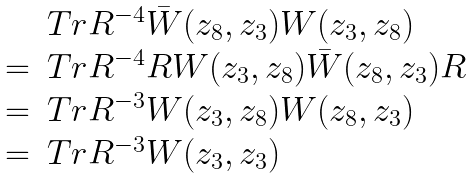<formula> <loc_0><loc_0><loc_500><loc_500>\begin{array} { r l } & T r R ^ { - 4 } \bar { W } ( z _ { 8 } , z _ { 3 } ) W ( z _ { 3 } , z _ { 8 } ) \\ = & T r R ^ { - 4 } R W ( z _ { 3 } , z _ { 8 } ) \bar { W } ( z _ { 8 } , z _ { 3 } ) R \\ = & T r R ^ { - 3 } W ( z _ { 3 } , z _ { 8 } ) W ( z _ { 8 } , z _ { 3 } ) \\ = & T r R ^ { - 3 } W ( z _ { 3 } , z _ { 3 } ) \end{array}</formula> 